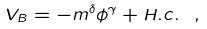Convert formula to latex. <formula><loc_0><loc_0><loc_500><loc_500>V _ { B } = - m ^ { \delta } \phi ^ { \gamma } + H . c . \ ,</formula> 